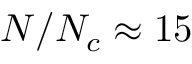Convert formula to latex. <formula><loc_0><loc_0><loc_500><loc_500>N / { N _ { c } } \approx 1 5</formula> 